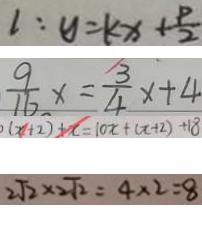<formula> <loc_0><loc_0><loc_500><loc_500>1 : y = k x + \frac { P } { 2 } 
 \frac { 9 } { 1 6 } x = \frac { 3 } { 4 } x + 4 
 ( x + 2 ) + x = 1 0 x + ( x + 2 ) + 1 8 
 2 \sqrt { 2 } \times 2 \sqrt { 2 } = 4 \times 2 = 8</formula> 